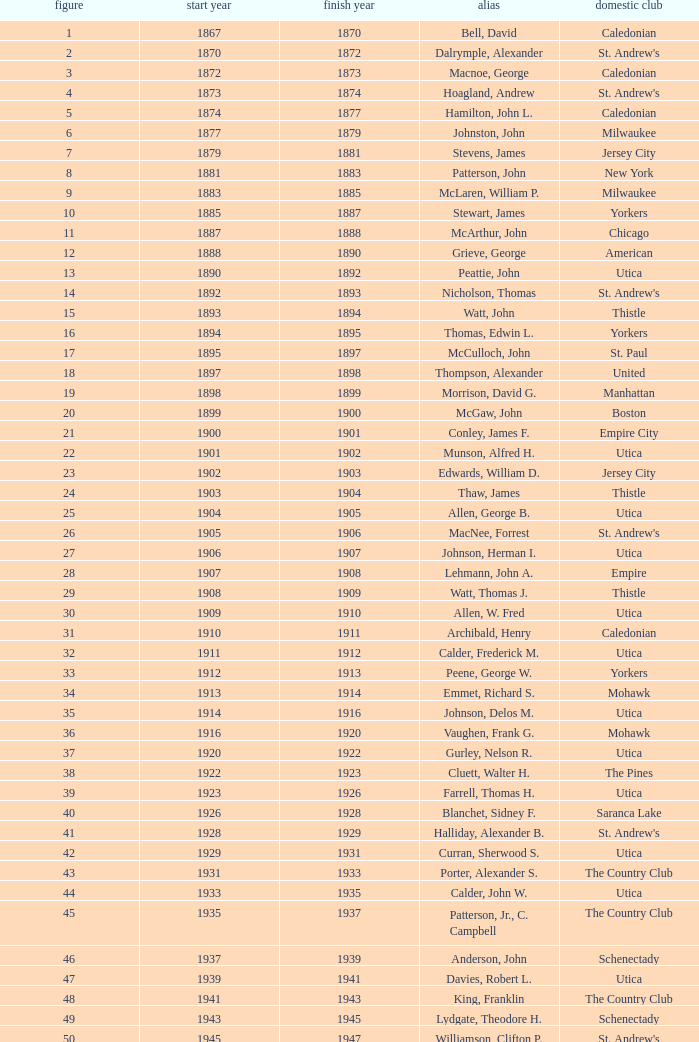Which Number has a Name of cooper, c. kenneth, and a Year End larger than 1984? None. 